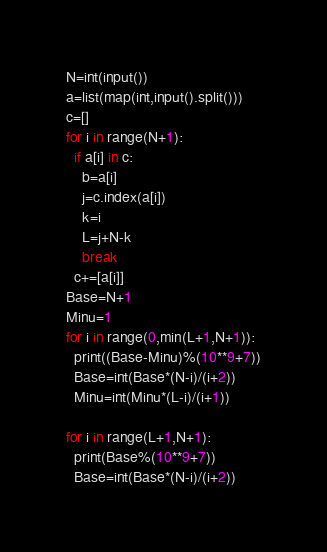Convert code to text. <code><loc_0><loc_0><loc_500><loc_500><_Python_>N=int(input())
a=list(map(int,input().split()))
c=[]
for i in range(N+1):
  if a[i] in c:
    b=a[i]
    j=c.index(a[i])
    k=i
    L=j+N-k
    break
  c+=[a[i]]
Base=N+1
Minu=1
for i in range(0,min(L+1,N+1)):
  print((Base-Minu)%(10**9+7))
  Base=int(Base*(N-i)/(i+2))
  Minu=int(Minu*(L-i)/(i+1))

for i in range(L+1,N+1):
  print(Base%(10**9+7))
  Base=int(Base*(N-i)/(i+2))</code> 